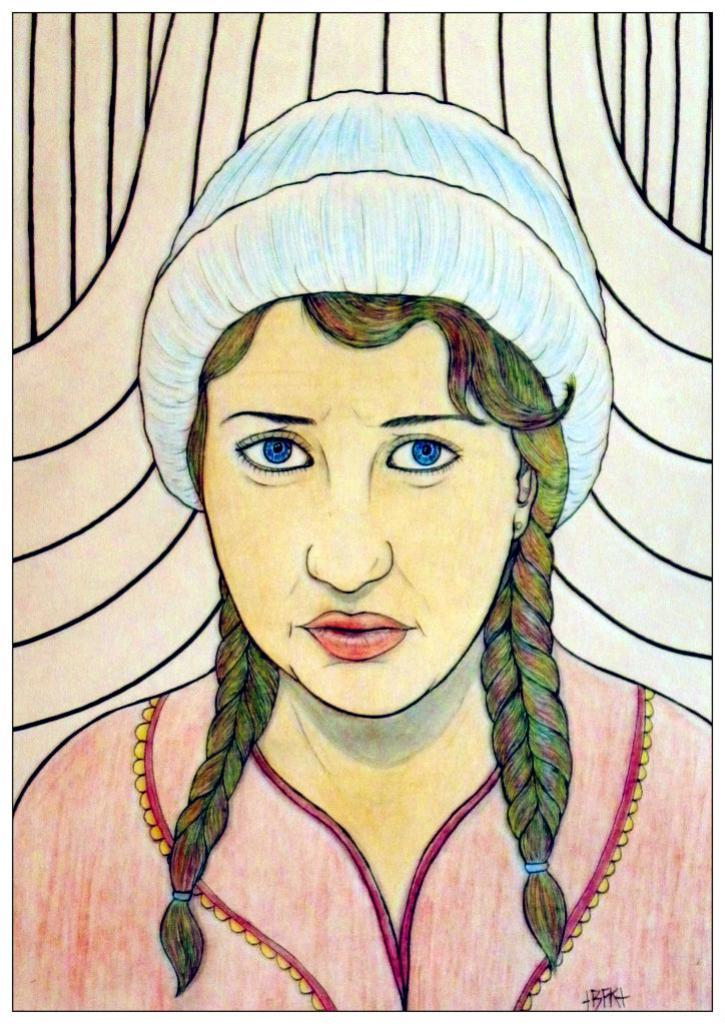What is the main subject of the painting? The painting depicts a person. What color is the dress the person is wearing? The person is wearing a pink dress. What type of headwear is the person wearing? The person is wearing a blue cap. Does the person's mom appear in the painting? There is no indication of the person's mom in the painting. Can you tell me how many people are joining the person in the painting? The painting only depicts one person, so there is no one else joining them. 